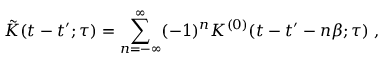<formula> <loc_0><loc_0><loc_500><loc_500>\tilde { K } ( t - t ^ { \prime } ; \tau ) = \sum _ { n = - \infty } ^ { \infty } ( - 1 ) ^ { n } K ^ { ( 0 ) } ( t - t ^ { \prime } - n \beta ; \tau ) \, ,</formula> 